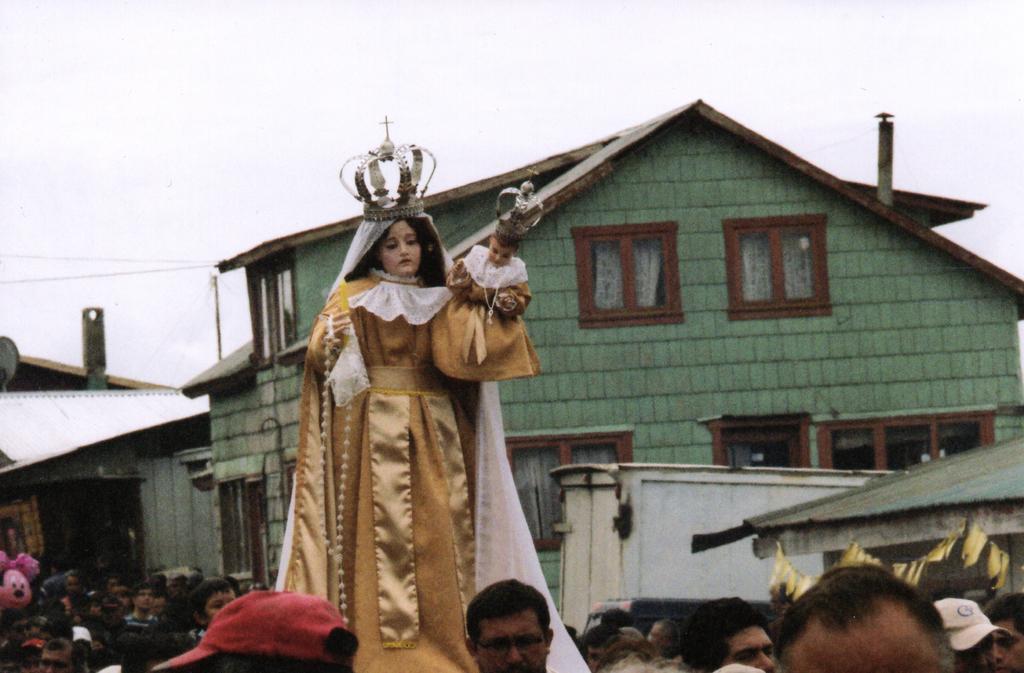Could you give a brief overview of what you see in this image? In this image we can see few persons and among them at the bottom we can only see few persons heads. In the background we can see buildings, windows, container, wires, pole, objects and the sky. 